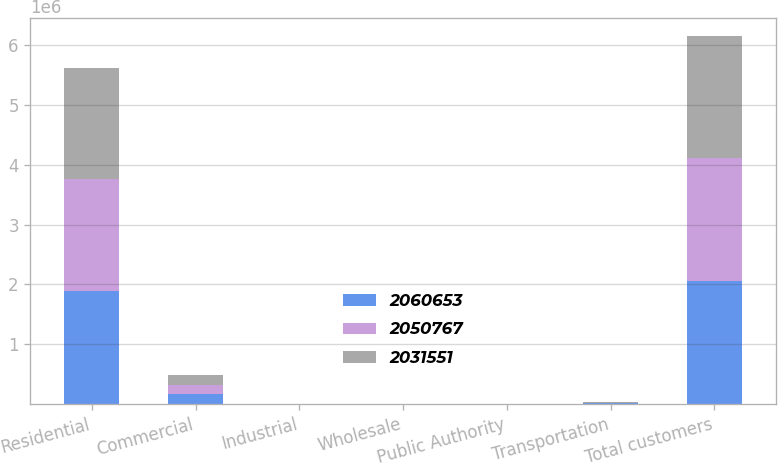<chart> <loc_0><loc_0><loc_500><loc_500><stacked_bar_chart><ecel><fcel>Residential<fcel>Commercial<fcel>Industrial<fcel>Wholesale<fcel>Public Authority<fcel>Transportation<fcel>Total customers<nl><fcel>2.06065e+06<fcel>1.88612e+06<fcel>159748<fcel>1420<fcel>28<fcel>2963<fcel>10376<fcel>2.06065e+06<nl><fcel>2.05077e+06<fcel>1.87605e+06<fcel>160517<fcel>1455<fcel>27<fcel>2952<fcel>9762<fcel>2.05077e+06<nl><fcel>2.03155e+06<fcel>1.85948e+06<fcel>159214<fcel>1528<fcel>18<fcel>2645<fcel>8666<fcel>2.03155e+06<nl></chart> 